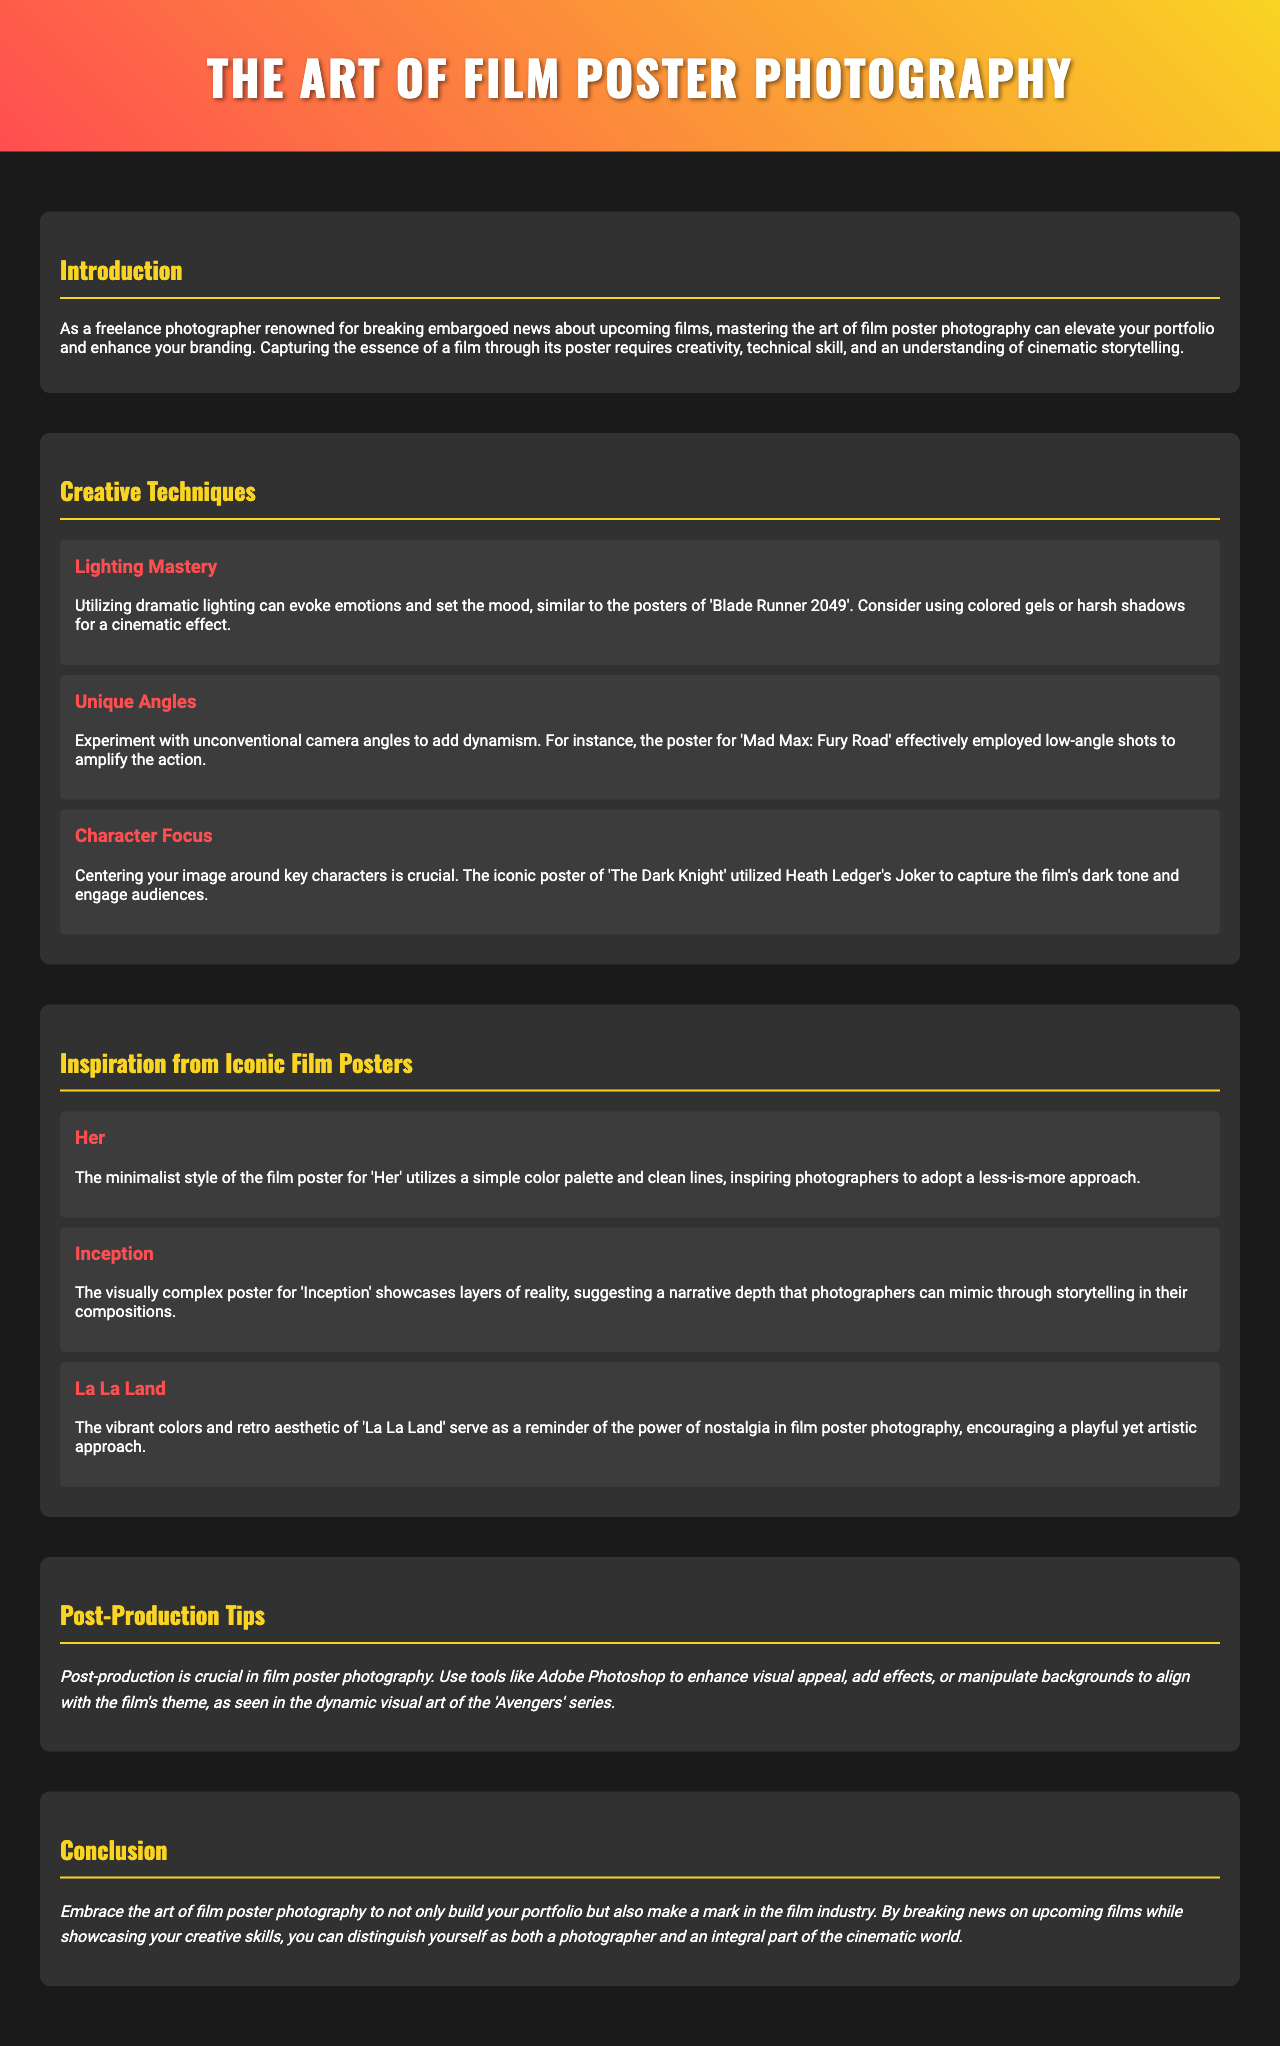what is the title of the brochure? The title is prominently displayed at the top of the document, indicating its focus.
Answer: The Art of Film Poster Photography who is the target audience for this brochure? The introduction mentions the target audience as a specific type of photographer.
Answer: Freelance photographers what film's poster uses colored gels for a cinematic effect? The Lighting Mastery section specifically mentions a film example related to lighting techniques.
Answer: Blade Runner 2049 which film's poster is known for utilizing low-angle shots? The Unique Angles technique references a specific film that employed this type of shot effectively.
Answer: Mad Max: Fury Road what is a key focus mentioned for character in film poster photography? The Character Focus technique emphasizes the importance of a specific aspect when composing the photo.
Answer: Key characters what simplistic style is recommended in the poster for 'Her'? The inspiration from iconic film posters highlights the style of one particular movie's poster.
Answer: Minimalist style which visual element is emphasized in the poster for 'Inception'? The Inception inspiration discusses a particular characteristic that photographers should aim to replicate.
Answer: Layers of reality what software is suggested for post-production in film poster photography? The post-production tips segment names specific software that can enhance images after the shoot.
Answer: Adobe Photoshop what type of approach is encouraged by the 'La La Land' poster? The inspiration section for 'La La Land' conveys a particular thematic approach for photographers.
Answer: Nostalgia 